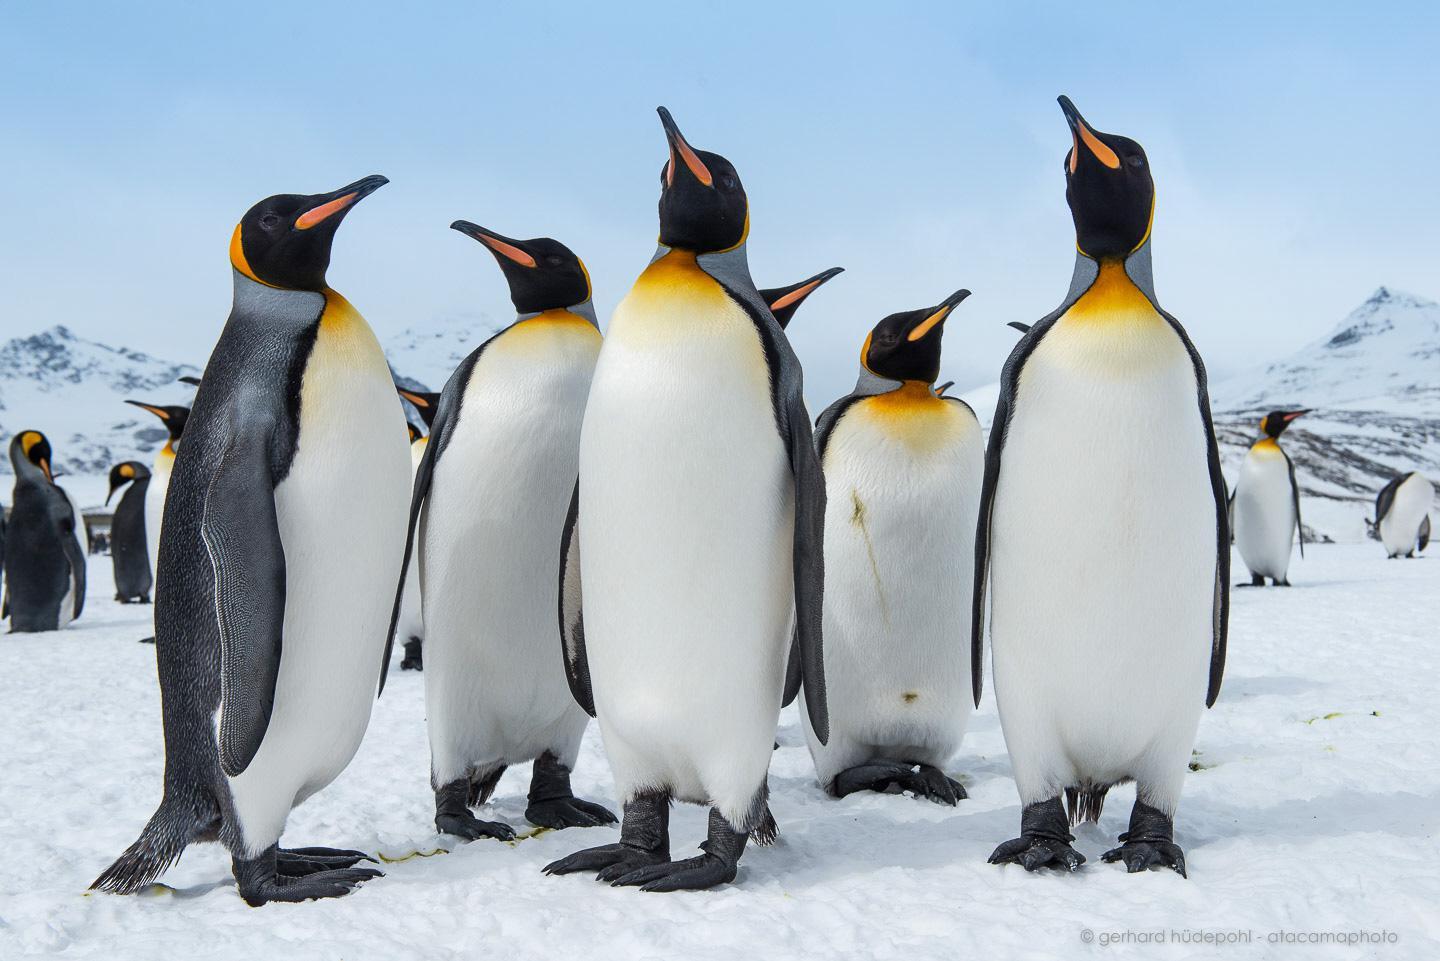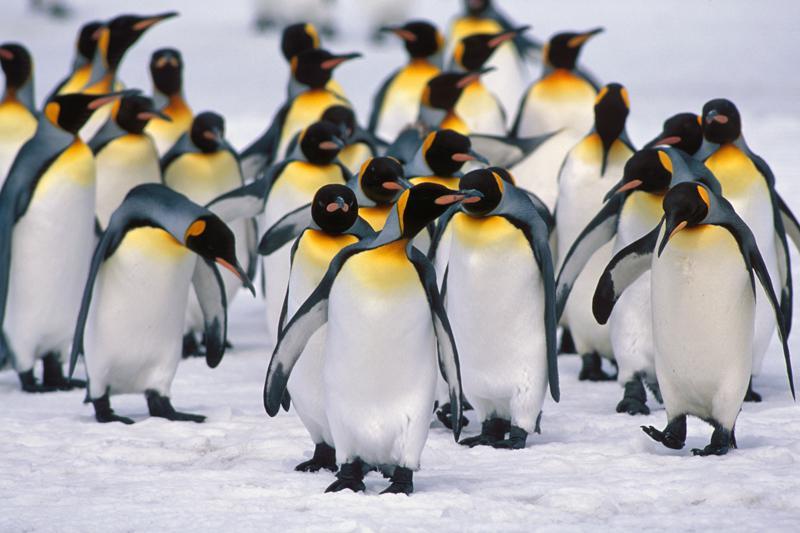The first image is the image on the left, the second image is the image on the right. Assess this claim about the two images: "Images include penguins walking through water.". Correct or not? Answer yes or no. No. The first image is the image on the left, the second image is the image on the right. Analyze the images presented: Is the assertion "The penguins in at least one of the images are walking through the waves." valid? Answer yes or no. No. 